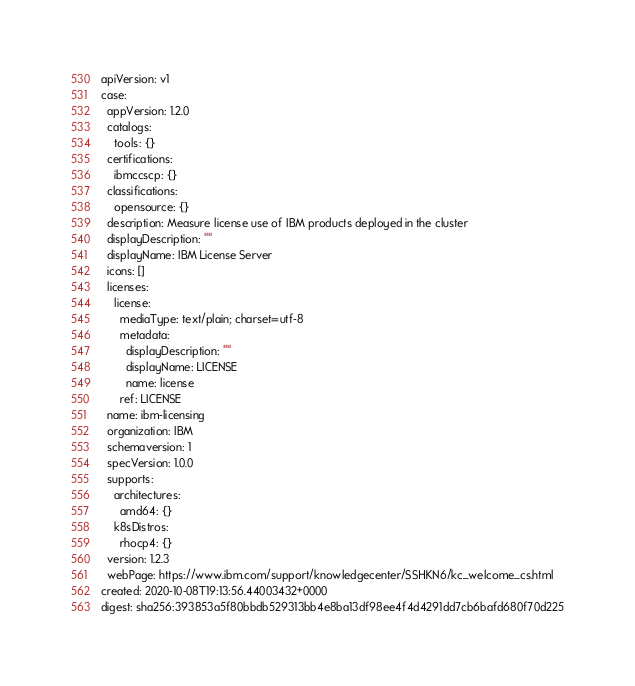<code> <loc_0><loc_0><loc_500><loc_500><_YAML_>apiVersion: v1
case:
  appVersion: 1.2.0
  catalogs:
    tools: {}
  certifications:
    ibmccscp: {}
  classifications:
    opensource: {}
  description: Measure license use of IBM products deployed in the cluster
  displayDescription: ""
  displayName: IBM License Server
  icons: []
  licenses:
    license:
      mediaType: text/plain; charset=utf-8
      metadata:
        displayDescription: ""
        displayName: LICENSE
        name: license
      ref: LICENSE
  name: ibm-licensing
  organization: IBM
  schemaversion: 1
  specVersion: 1.0.0
  supports:
    architectures:
      amd64: {}
    k8sDistros:
      rhocp4: {}
  version: 1.2.3
  webPage: https://www.ibm.com/support/knowledgecenter/SSHKN6/kc_welcome_cs.html
created: 2020-10-08T19:13:56.44003432+0000
digest: sha256:393853a5f80bbdb529313bb4e8ba13df98ee4f4d4291dd7cb6bafd680f70d225
</code> 